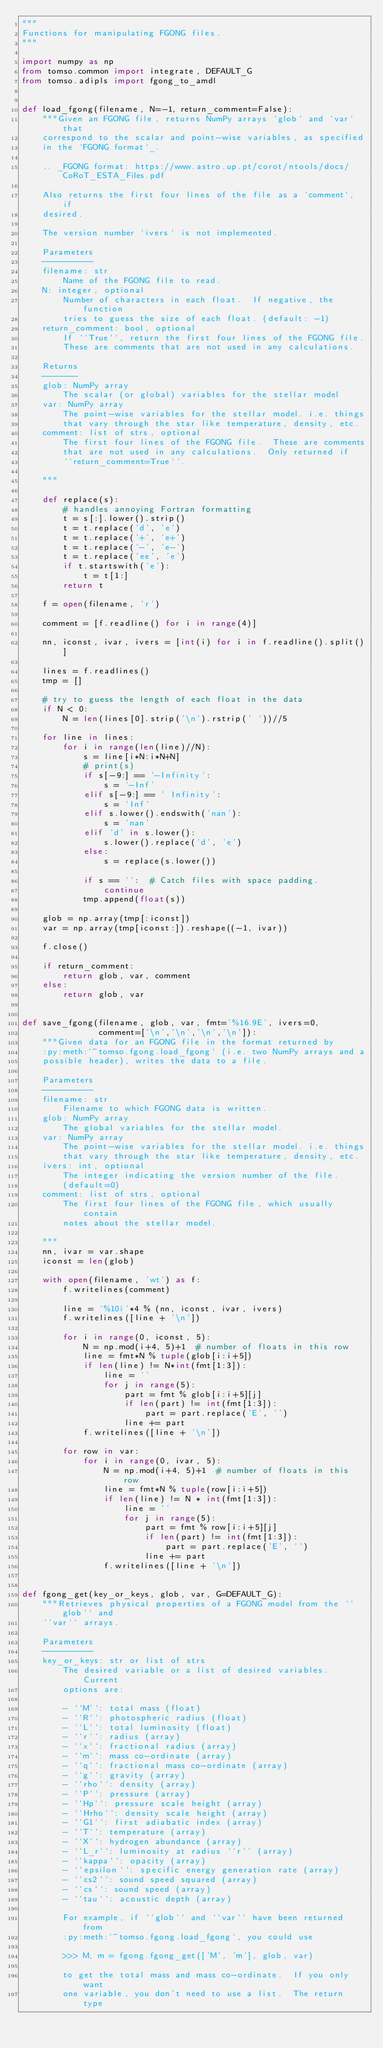<code> <loc_0><loc_0><loc_500><loc_500><_Python_>"""
Functions for manipulating FGONG files.
"""

import numpy as np
from tomso.common import integrate, DEFAULT_G
from tomso.adipls import fgong_to_amdl


def load_fgong(filename, N=-1, return_comment=False):
    """Given an FGONG file, returns NumPy arrays `glob` and `var` that
    correspond to the scalar and point-wise variables, as specified
    in the `FGONG format`_.

    .. _FGONG format: https://www.astro.up.pt/corot/ntools/docs/CoRoT_ESTA_Files.pdf

    Also returns the first four lines of the file as a `comment`, if
    desired.

    The version number `ivers` is not implemented.

    Parameters
    ----------
    filename: str
        Name of the FGONG file to read.
    N: integer, optional
        Number of characters in each float.  If negative, the function
        tries to guess the size of each float. (default: -1)
    return_comment: bool, optional
        If ``True``, return the first four lines of the FGONG file.
        These are comments that are not used in any calculations.

    Returns
    -------
    glob: NumPy array
        The scalar (or global) variables for the stellar model
    var: NumPy array
        The point-wise variables for the stellar model. i.e. things
        that vary through the star like temperature, density, etc.
    comment: list of strs, optional
        The first four lines of the FGONG file.  These are comments
        that are not used in any calculations.  Only returned if
        ``return_comment=True``.

    """
    
    def replace(s):
        # handles annoying Fortran formatting
        t = s[:].lower().strip()
        t = t.replace('d', 'e')
        t = t.replace('+', 'e+')
        t = t.replace('-', 'e-')
        t = t.replace('ee', 'e')
        if t.startswith('e'):
            t = t[1:]
        return t
    
    f = open(filename, 'r')

    comment = [f.readline() for i in range(4)]

    nn, iconst, ivar, ivers = [int(i) for i in f.readline().split()]

    lines = f.readlines()
    tmp = []

    # try to guess the length of each float in the data
    if N < 0:
        N = len(lines[0].strip('\n').rstrip(' '))//5
    
    for line in lines:
        for i in range(len(line)//N):
            s = line[i*N:i*N+N]
            # print(s)
            if s[-9:] == '-Infinity':
                s = '-Inf'
            elif s[-9:] == ' Infinity':
                s = 'Inf'
            elif s.lower().endswith('nan'):
                s = 'nan'
            elif 'd' in s.lower():
                s.lower().replace('d', 'e')
            else:
                s = replace(s.lower())
                
            if s == '':  # Catch files with space padding.
                continue
            tmp.append(float(s))

    glob = np.array(tmp[:iconst])
    var = np.array(tmp[iconst:]).reshape((-1, ivar))

    f.close()

    if return_comment:
        return glob, var, comment
    else:
        return glob, var


def save_fgong(filename, glob, var, fmt='%16.9E', ivers=0,
               comment=['\n','\n','\n','\n']):
    """Given data for an FGONG file in the format returned by
    :py:meth:`~tomso.fgong.load_fgong` (i.e. two NumPy arrays and a
    possible header), writes the data to a file.

    Parameters
    ----------
    filename: str
        Filename to which FGONG data is written.
    glob: NumPy array
        The global variables for the stellar model.
    var: NumPy array
        The point-wise variables for the stellar model. i.e. things
        that vary through the star like temperature, density, etc.
    ivers: int, optional
        The integer indicating the version number of the file.
        (default=0)
    comment: list of strs, optional
        The first four lines of the FGONG file, which usually contain
        notes about the stellar model.

    """
    nn, ivar = var.shape
    iconst = len(glob)

    with open(filename, 'wt') as f:
        f.writelines(comment)

        line = '%10i'*4 % (nn, iconst, ivar, ivers)
        f.writelines([line + '\n'])

        for i in range(0, iconst, 5):
            N = np.mod(i+4, 5)+1  # number of floats in this row
            line = fmt*N % tuple(glob[i:i+5])
            if len(line) != N*int(fmt[1:3]):
                line = ''
                for j in range(5):
                    part = fmt % glob[i:i+5][j]
                    if len(part) != int(fmt[1:3]):
                        part = part.replace('E', '')
                    line += part
            f.writelines([line + '\n'])

        for row in var:
            for i in range(0, ivar, 5):
                N = np.mod(i+4, 5)+1  # number of floats in this row
                line = fmt*N % tuple(row[i:i+5])
                if len(line) != N * int(fmt[1:3]):
                    line = ''
                    for j in range(5):
                        part = fmt % row[i:i+5][j]
                        if len(part) != int(fmt[1:3]):
                            part = part.replace('E', '')
                        line += part
                f.writelines([line + '\n'])


def fgong_get(key_or_keys, glob, var, G=DEFAULT_G):
    """Retrieves physical properties of a FGONG model from the ``glob`` and
    ``var`` arrays.

    Parameters
    ----------
    key_or_keys: str or list of strs
        The desired variable or a list of desired variables.  Current
        options are:

        - ``M``: total mass (float)
        - ``R``: photospheric radius (float)
        - ``L``: total luminosity (float)
        - ``r``: radius (array)
        - ``x``: fractional radius (array)
        - ``m``: mass co-ordinate (array)
        - ``q``: fractional mass co-ordinate (array)
        - ``g``: gravity (array)
        - ``rho``: density (array)
        - ``P``: pressure (array)
        - ``Hp``: pressure scale height (array)
        - ``Hrho``: density scale height (array)
        - ``G1``: first adiabatic index (array)
        - ``T``: temperature (array)
        - ``X``: hydrogen abundance (array)
        - ``L_r``: luminosity at radius ``r`` (array)
        - ``kappa``: opacity (array)
        - ``epsilon``: specific energy generation rate (array)
        - ``cs2``: sound speed squared (array)
        - ``cs``: sound speed (array)
        - ``tau``: acoustic depth (array)

        For example, if ``glob`` and ``var`` have been returned from
        :py:meth:`~tomso.fgong.load_fgong`, you could use

        >>> M, m = fgong.fgong_get(['M', 'm'], glob, var)

        to get the total mass and mass co-ordinate.  If you only want
        one variable, you don't need to use a list.  The return type</code> 